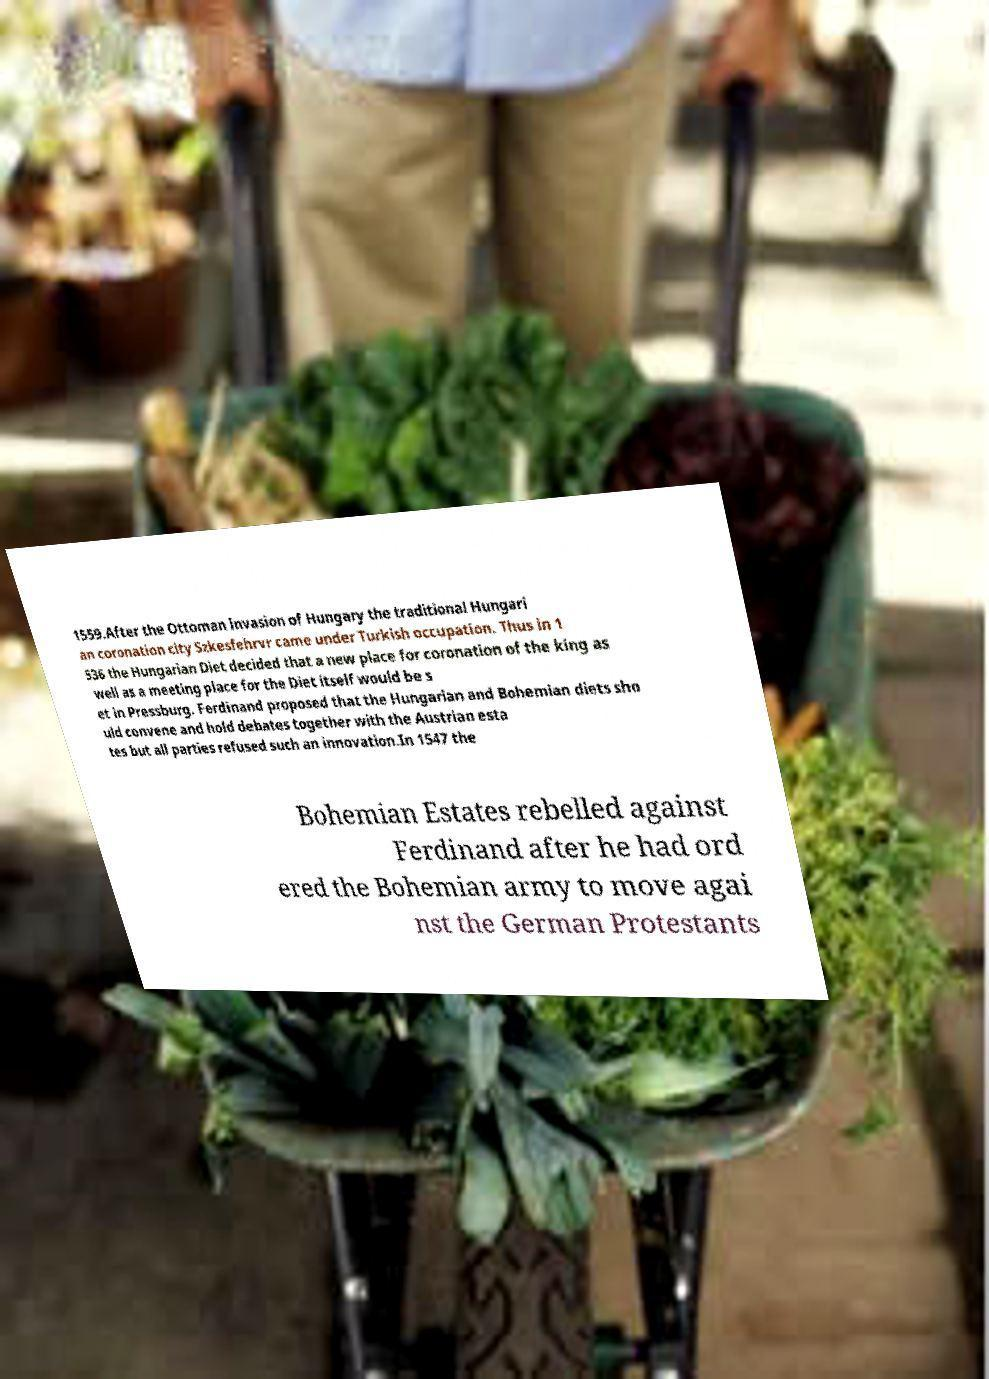Could you assist in decoding the text presented in this image and type it out clearly? 1559.After the Ottoman invasion of Hungary the traditional Hungari an coronation city Szkesfehrvr came under Turkish occupation. Thus in 1 536 the Hungarian Diet decided that a new place for coronation of the king as well as a meeting place for the Diet itself would be s et in Pressburg. Ferdinand proposed that the Hungarian and Bohemian diets sho uld convene and hold debates together with the Austrian esta tes but all parties refused such an innovation.In 1547 the Bohemian Estates rebelled against Ferdinand after he had ord ered the Bohemian army to move agai nst the German Protestants 